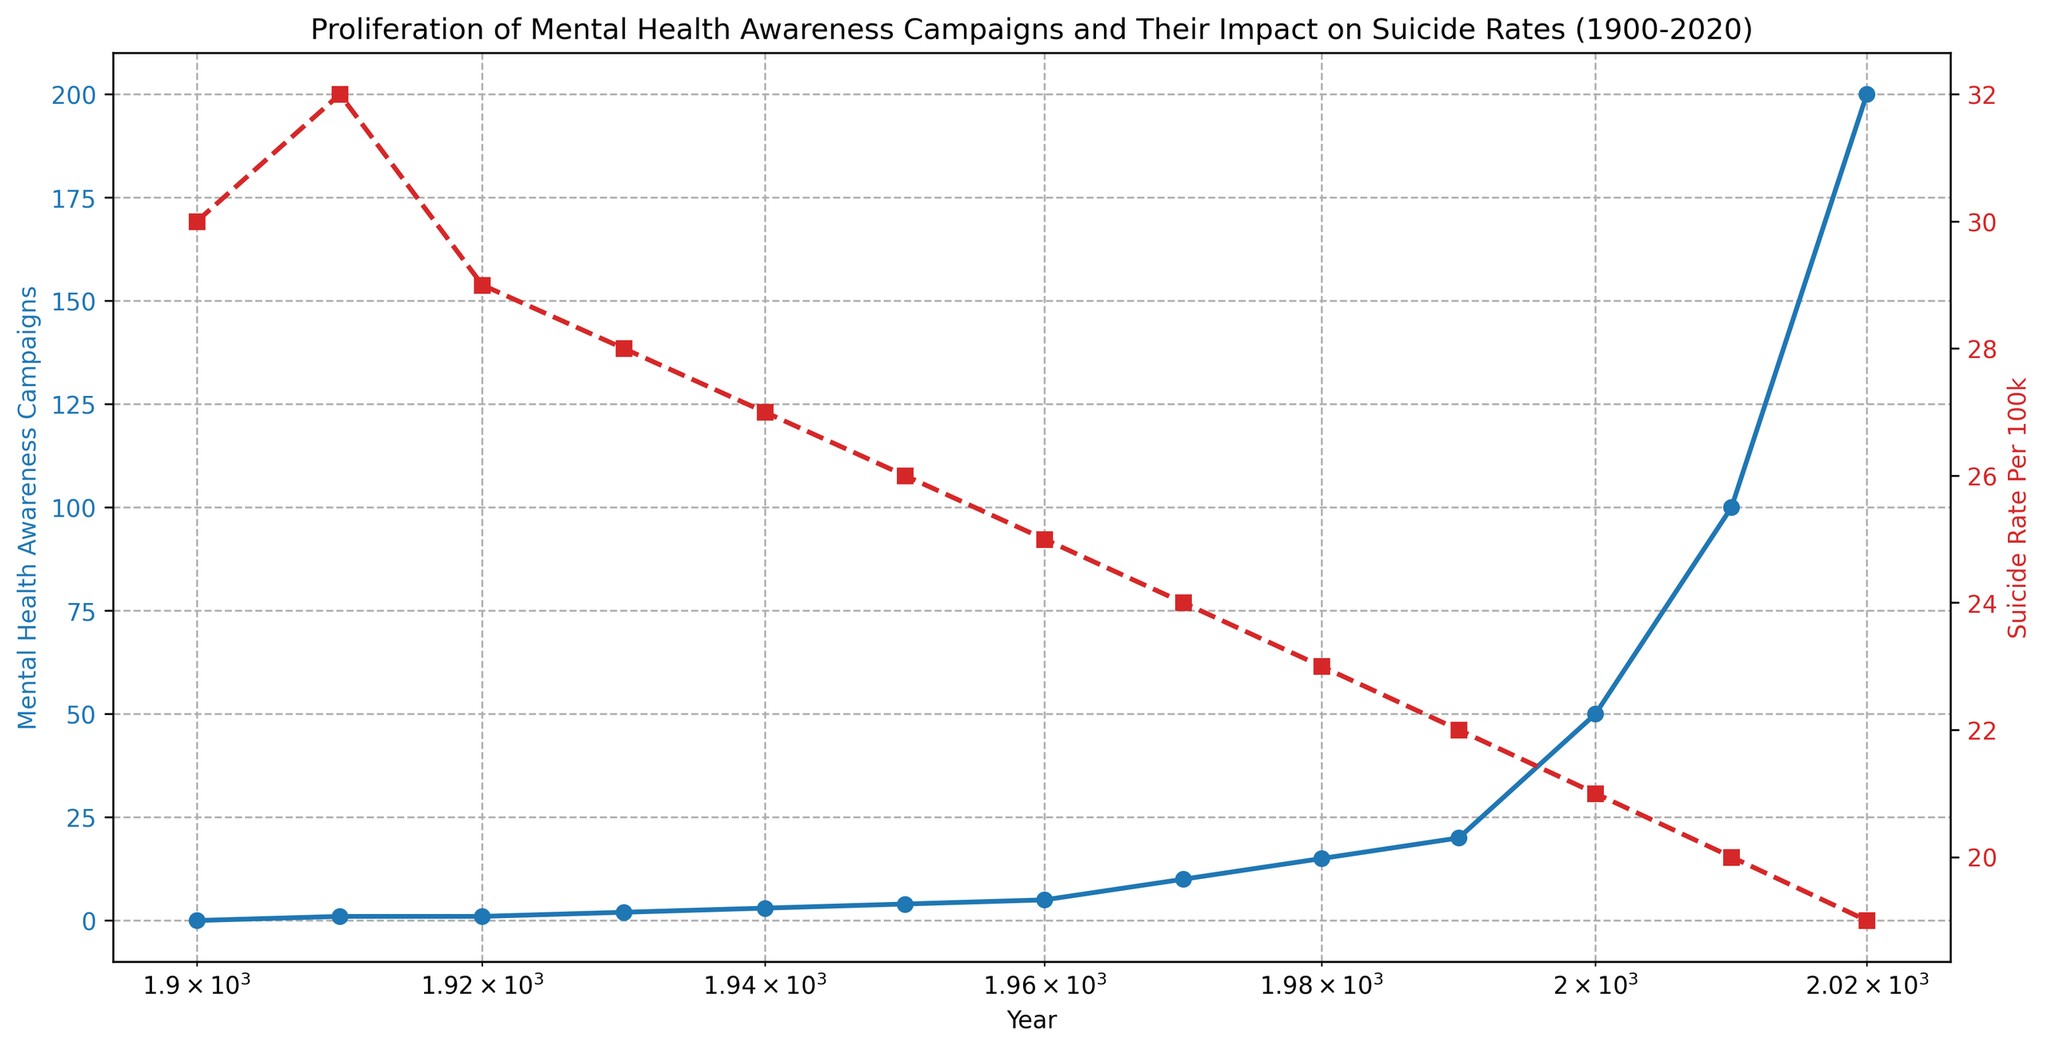What's the trend of Mental Health Awareness Campaigns over the years? The campaigns showed exponential growth, increasing from 0 in 1900 to 200 in 2020. This can be seen from the rapid upward curve on the log-scale x-axis.
Answer: Increasing exponentially What's the general trend of suicide rates over the 120-year period? The suicide rate per 100k has been generally decreasing from 30 in 1900 to 19 in 2020, shown by the downward trend in the red line.
Answer: Decreasing By how much did the suicide rate per 100k change between 1950 and 2000? In 1950, the suicide rate was 26 per 100k. In 2000, it was 21 per 100k. The change is 26 - 21 = 5.
Answer: 5 per 100k Which year had the largest increase in Mental Health Awareness Campaigns? The largest increase in campaigns occurred between 2000 and 2010, where it jumped from 50 to 100, an increase of 50.
Answer: Between 2000 and 2010 How does the number of campaigns in 2020 compare with the number in 2000? In 2000, there were 50 campaigns; by 2020, this number had increased to 200. Therefore, there were 4 times more campaigns in 2020 compared to 2000.
Answer: 4 times more What is the color of the line representing the suicide rate per 100k? The color used for the suicide rate per 100k is red, as seen from the legend and the plot itself.
Answer: Red How did the trend of suicide rates differ from the trend of mental health awareness campaigns over time? While mental health awareness campaigns have been growing exponentially, the trend in suicide rates has shown a steady decrease, implying opposite directions in the trends.
Answer: Opposite trends Between which two decades did the suicide rate decrease by 1 per 100k each decade consecutively? The suicide rate decreased from 28 in 1930 to 27 in 1940 and then to 26 in 1950, showing a decrease of 1 per 100k each decade.
Answer: 1930-1940 and 1940-1950 What mathematical relationship can be inferred between the campaign numbers and suicide rates visually? As the number of campaigns increased, the suicide rates generally decreased, suggesting a possible inverse relationship.
Answer: Inverse relationship How many campaigns were present when the suicide rate was 23 per 100k? In 1980, the suicide rate was 23 per 100k, and the number of campaigns was 15 at that time.
Answer: 15 campaigns 